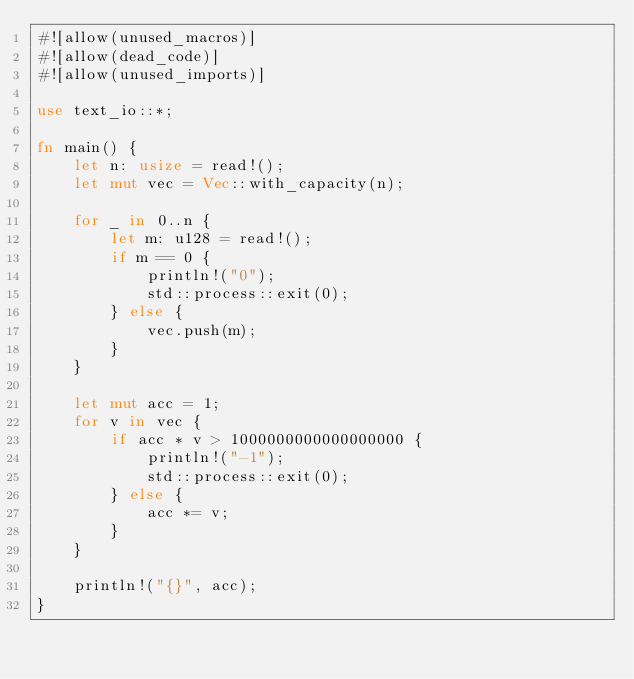Convert code to text. <code><loc_0><loc_0><loc_500><loc_500><_Rust_>#![allow(unused_macros)]
#![allow(dead_code)]
#![allow(unused_imports)]

use text_io::*;

fn main() {
    let n: usize = read!();
    let mut vec = Vec::with_capacity(n);

    for _ in 0..n {
        let m: u128 = read!();
        if m == 0 {
            println!("0");
            std::process::exit(0);
        } else {
            vec.push(m);
        }
    }

    let mut acc = 1;
    for v in vec {
        if acc * v > 1000000000000000000 {
            println!("-1");
            std::process::exit(0);
        } else {
            acc *= v;
        }
    }

    println!("{}", acc);
}
</code> 